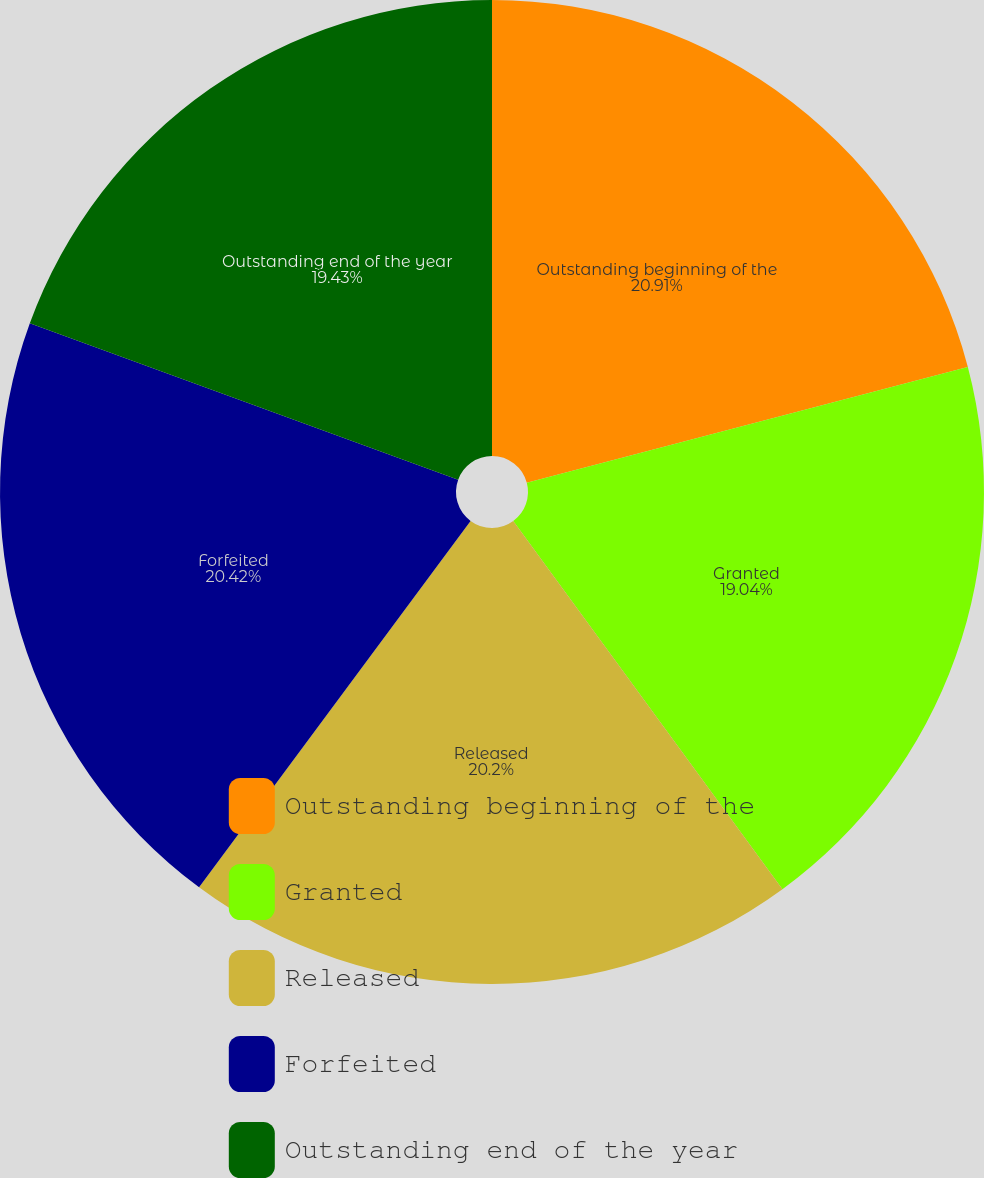<chart> <loc_0><loc_0><loc_500><loc_500><pie_chart><fcel>Outstanding beginning of the<fcel>Granted<fcel>Released<fcel>Forfeited<fcel>Outstanding end of the year<nl><fcel>20.91%<fcel>19.04%<fcel>20.2%<fcel>20.42%<fcel>19.43%<nl></chart> 